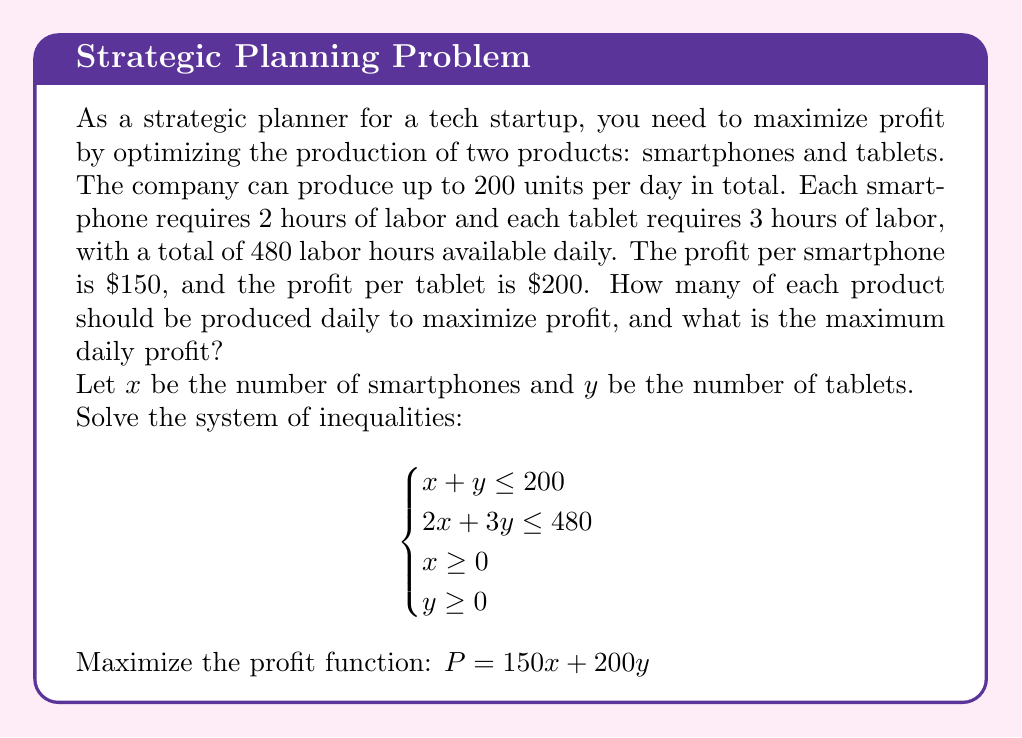Help me with this question. 1. First, let's graph the system of inequalities:
   - $x + y \leq 200$ (production constraint)
   - $2x + 3y \leq 480$ (labor constraint)
   - $x \geq 0$ and $y \geq 0$ (non-negative production)

2. The feasible region is bounded by these inequalities. The optimal solution will be at one of the corner points of this region.

3. Find the corner points:
   a) $(0, 0)$
   b) $(200, 0)$
   c) $(0, 160)$
   d) Intersection of $x + y = 200$ and $2x + 3y = 480$:
      Solve: $2(200-y) + 3y = 480$
              $400 - 2y + 3y = 480$
              $y = 80$, $x = 120$

4. Corner points: $(0, 0)$, $(200, 0)$, $(120, 80)$, $(0, 160)$

5. Evaluate the profit function $P = 150x + 200y$ at each point:
   - $P(0, 0) = 0$
   - $P(200, 0) = 30,000$
   - $P(120, 80) = 34,000$
   - $P(0, 160) = 32,000$

6. The maximum profit occurs at $(120, 80)$, producing 120 smartphones and 80 tablets daily.

7. Maximum daily profit: $P = 150(120) + 200(80) = 34,000$
Answer: Produce 120 smartphones and 80 tablets daily; Maximum profit: $34,000 